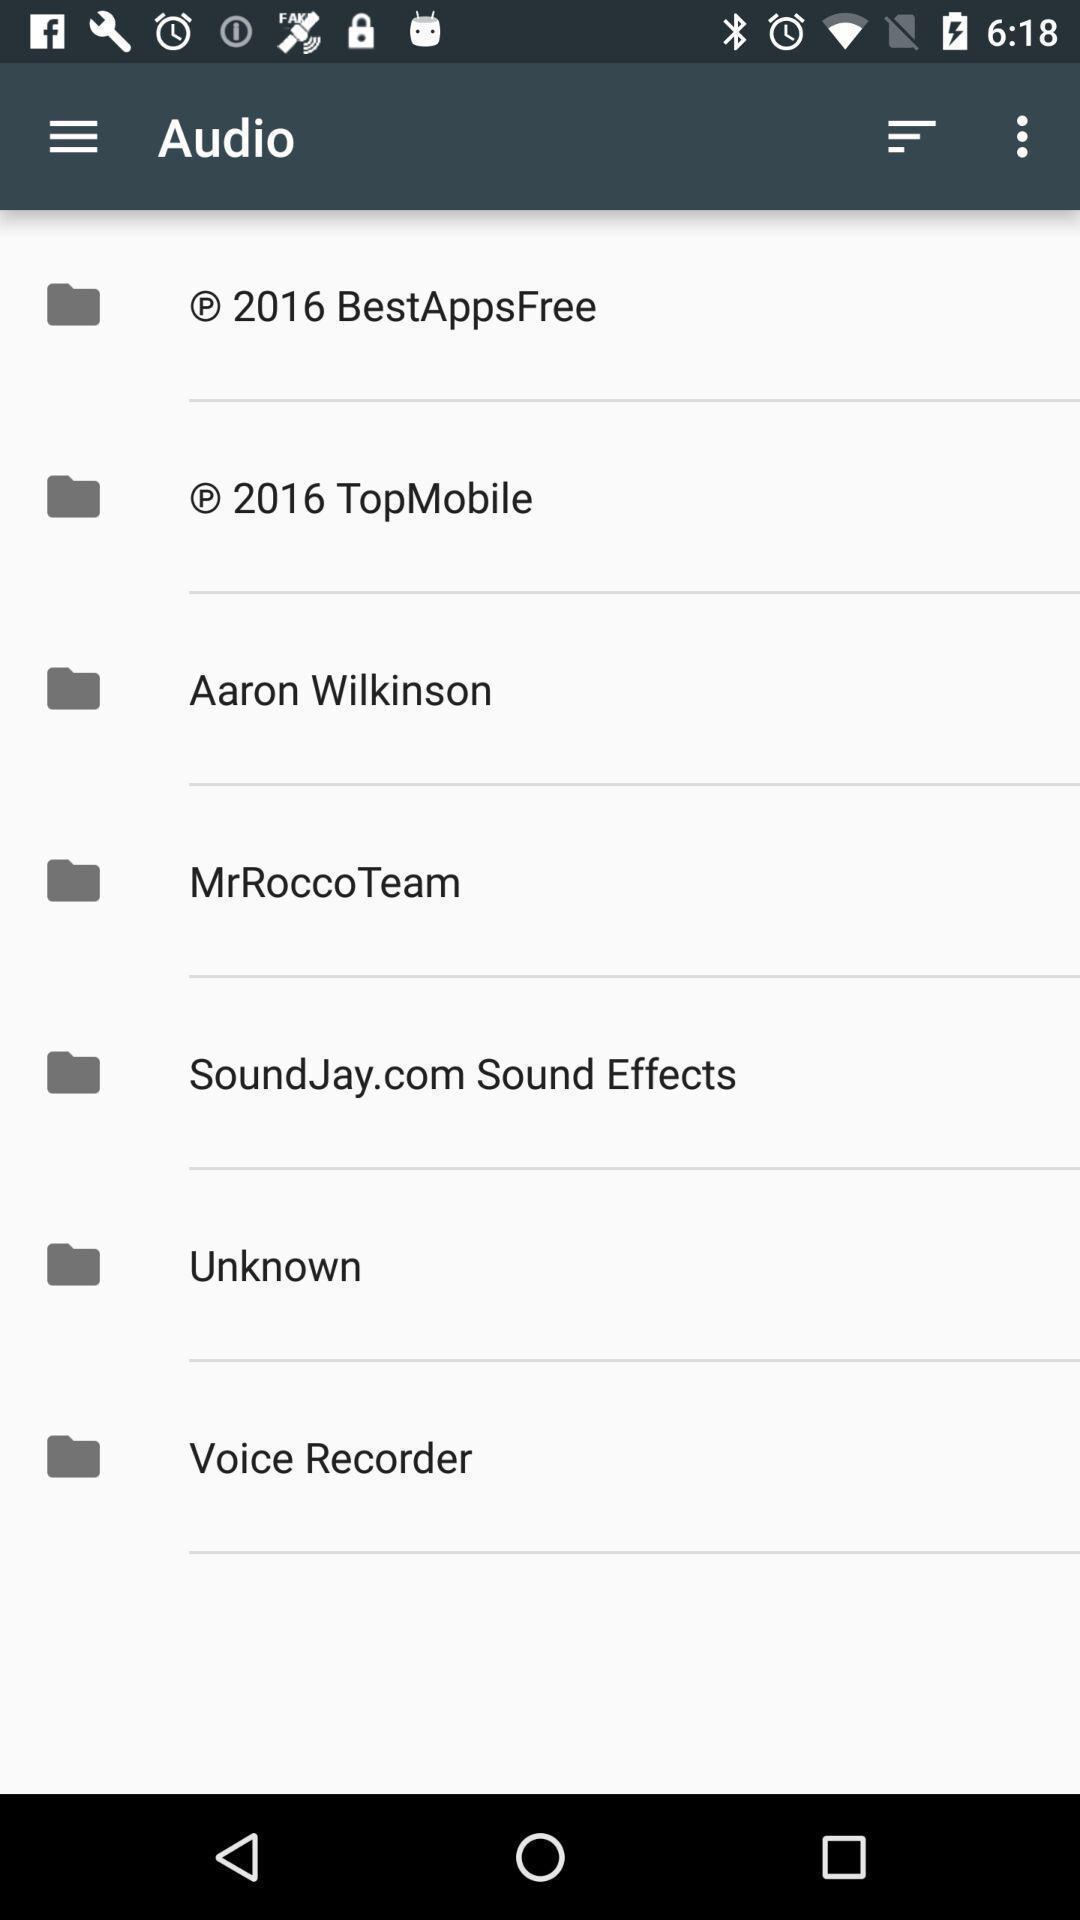Please provide a description for this image. Screen showing various options. 